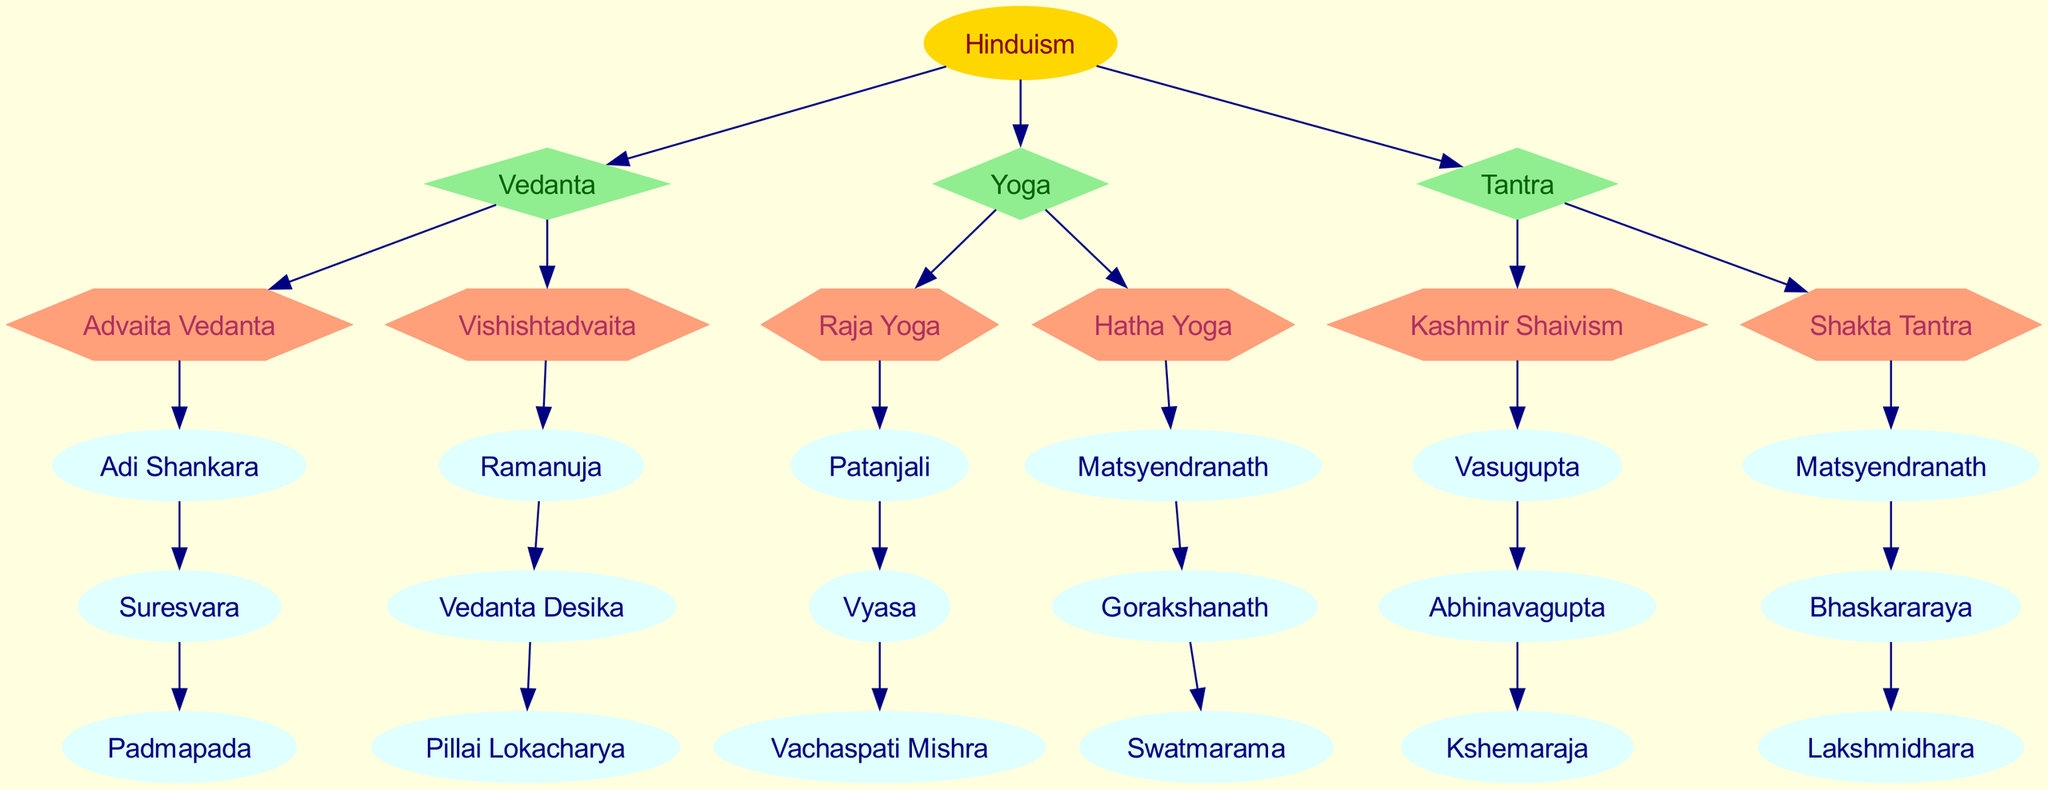What is the root of the family tree? The root node is labeled 'Hinduism', which indicates the primary entity from which all branches originate in the diagram.
Answer: Hinduism How many branches are there in the diagram? The diagram shows a total of three branches under the root, which are Vedanta, Yoga, and Tantra.
Answer: 3 Which school is under the branch of Yoga? Within the Yoga branch, there are two schools: Raja Yoga and Hatha Yoga, which are connected to this branch. Selecting either provides the answer.
Answer: Raja Yoga Who is the first person in the lineage of Vishishtadvaita? The lineage of Vishishtadvaita starts with Ramanuja, making him the first individual listed in that school.
Answer: Ramanuja Which lineage is associated with Kashmir Shaivism? The lineage associated with Kashmir Shaivism includes Vasugupta, Abhinavagupta, and Kshemaraja, sequentially representing the spiritual teachers in that tradition.
Answer: Vasugupta How many individuals are in the lineage of Hatha Yoga? The lineage of Hatha Yoga includes three individuals: Matsyendranath, Gorakshanath, and Swatmarama, making the count three.
Answer: 3 Which branch has the most schools? The branches Vedanta and Yoga each contain two schools. However, Tantra also has two schools, thus no single branch has more than the others.
Answer: None What shape represents the branch nodes in the diagram? The branch nodes, representing each branch of the tree, are depicted in diamond shapes which are clearly customizable in the diagram's structure.
Answer: Diamond Which person belongs to the lineage of Advaita Vedanta? The lineage of Advaita Vedanta includes Adi Shankara, Suresvara, and Padmapada, identifying any of them as correct answers based on that lineage's arrangement.
Answer: Adi Shankara 